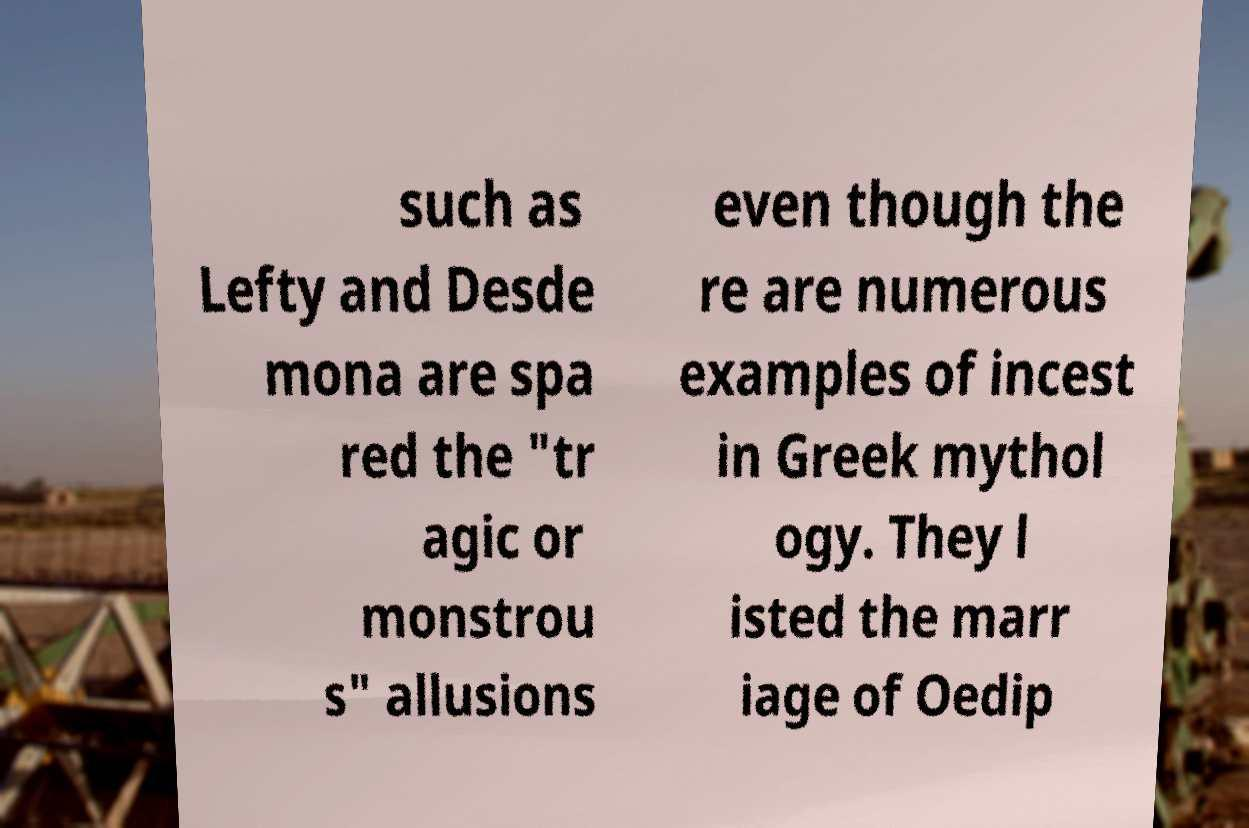What messages or text are displayed in this image? I need them in a readable, typed format. such as Lefty and Desde mona are spa red the "tr agic or monstrou s" allusions even though the re are numerous examples of incest in Greek mythol ogy. They l isted the marr iage of Oedip 